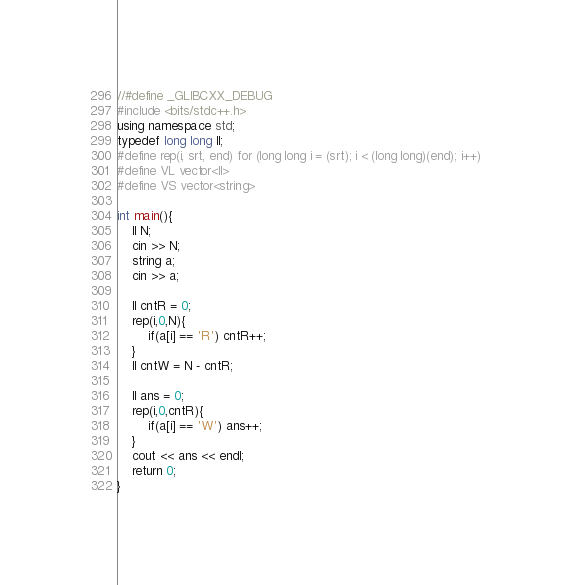<code> <loc_0><loc_0><loc_500><loc_500><_C++_>//#define _GLIBCXX_DEBUG
#include <bits/stdc++.h>
using namespace std;
typedef long long ll;
#define rep(i, srt, end) for (long long i = (srt); i < (long long)(end); i++)
#define VL vector<ll>
#define VS vector<string>

int main(){
    ll N;
    cin >> N;
    string a;
    cin >> a;

    ll cntR = 0;
    rep(i,0,N){
        if(a[i] == 'R') cntR++;
    }
    ll cntW = N - cntR;
    
    ll ans = 0;
    rep(i,0,cntR){
        if(a[i] == 'W') ans++;
    }
    cout << ans << endl;
    return 0;
}</code> 